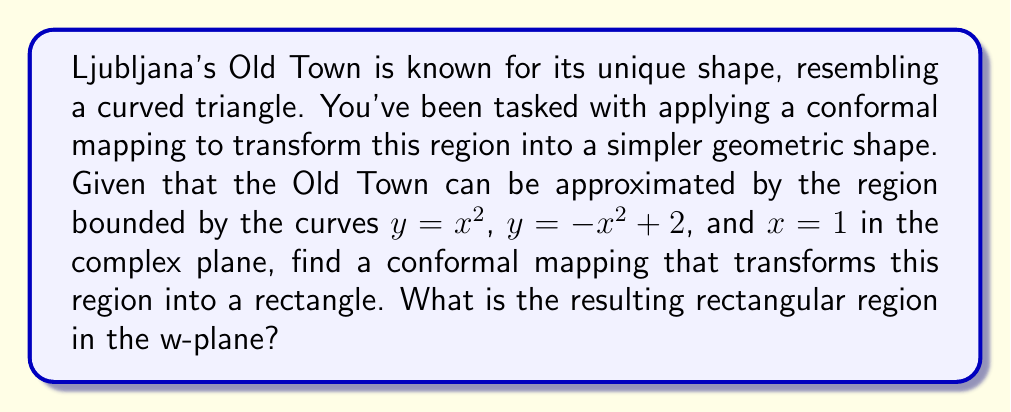Could you help me with this problem? Let's approach this step-by-step:

1) First, we need to identify a suitable conformal mapping. Given the parabolic nature of the boundaries, a square root function would be appropriate. Let's use:

   $w = \sqrt{z}$

2) Now, let's map the boundaries:

   a) For $y = x^2$, we have $z = x + ix^2$. Mapping this:
      $w = \sqrt{x + ix^2} = x + ix = x(1+i)$

   b) For $y = -x^2 + 2$, we have $z = x + i(-x^2 + 2)$. Mapping this:
      $w = \sqrt{x + i(-x^2 + 2)} = \sqrt{2-x^2} + ix$

   c) For $x = 1$, we have $z = 1 + iy$. Mapping this:
      $w = \sqrt{1 + iy} = \sqrt{\frac{1+y^2}{2}} + i\sqrt{\frac{-1+y^2}{2}}$

3) Let's analyze these mapped boundaries:

   a) $x(1+i)$ is a straight line through the origin with slope 1.
   b) $\sqrt{2-x^2} + ix$ is a quarter circle with radius $\sqrt{2}$.
   c) The line $x = 1$ maps to a curve from $1$ to $1+i$.

4) To complete the rectangle, we need to include the positive real and imaginary axes.

5) Therefore, the resulting region in the w-plane is bounded by:
   - The positive real axis from 0 to 1
   - The line $y = x$ from $(0,0)$ to $(1,1)$
   - The imaginary axis from 0 to i
   - The quarter circle from $i$ to $1+i$

This forms a rectangle-like region with one curved side.
Answer: The conformal mapping $w = \sqrt{z}$ transforms the given region into a rectangle-like shape in the w-plane, bounded by the positive real axis from 0 to 1, the line $y = x$ from $(0,0)$ to $(1,1)$, the imaginary axis from 0 to $i$, and a quarter circle from $i$ to $1+i$. 